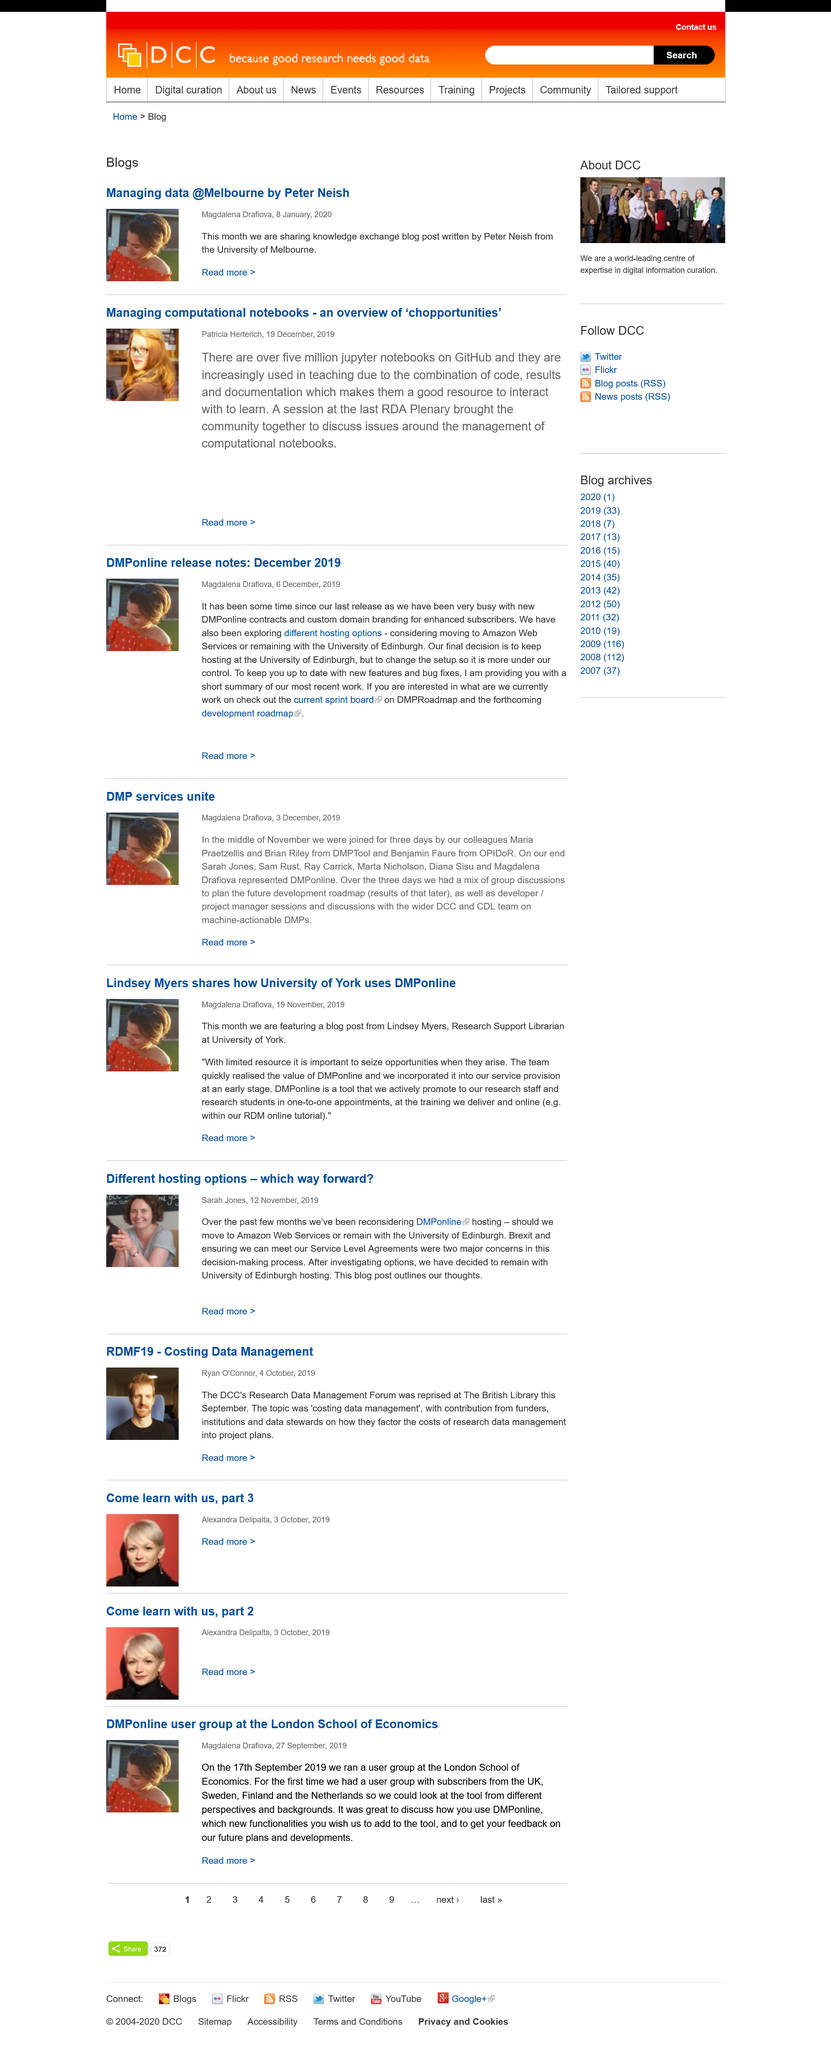Mention a couple of crucial points in this snapshot. It is known that Patricia Hererich published Managing Computational Notebooks. It is known that the book "Managing Data" was published by Peter Neish, who is based in Melbourne. This was created on January 8, 2020. 